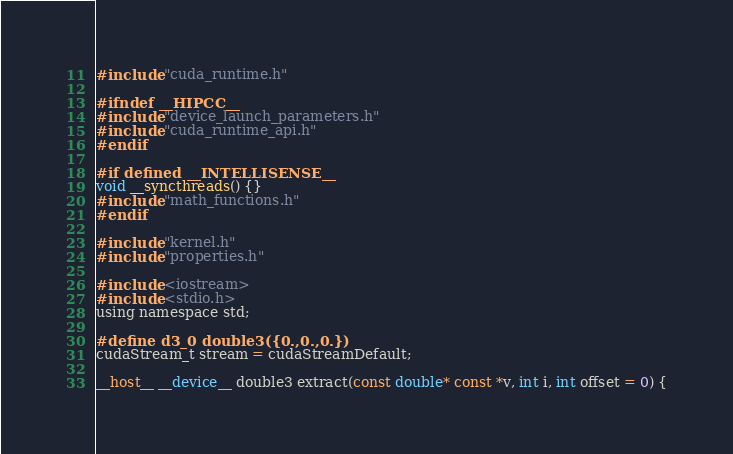Convert code to text. <code><loc_0><loc_0><loc_500><loc_500><_Cuda_>#include "cuda_runtime.h"

#ifndef __HIPCC__
#include "device_launch_parameters.h"
#include "cuda_runtime_api.h"
#endif

#if defined __INTELLISENSE__
void __syncthreads() {}
#include "math_functions.h"
#endif

#include "kernel.h"
#include "properties.h"

#include <iostream>
#include <stdio.h>
using namespace std;

#define d3_0 double3({0.,0.,0.})
cudaStream_t stream = cudaStreamDefault;

__host__ __device__ double3 extract(const double* const *v, int i, int offset = 0) {</code> 